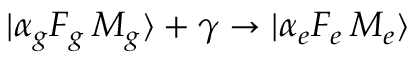Convert formula to latex. <formula><loc_0><loc_0><loc_500><loc_500>| \alpha _ { g } F _ { g } \, M _ { g } \rangle + \gamma \to | \alpha _ { e } F _ { e } \, M _ { e } \rangle</formula> 